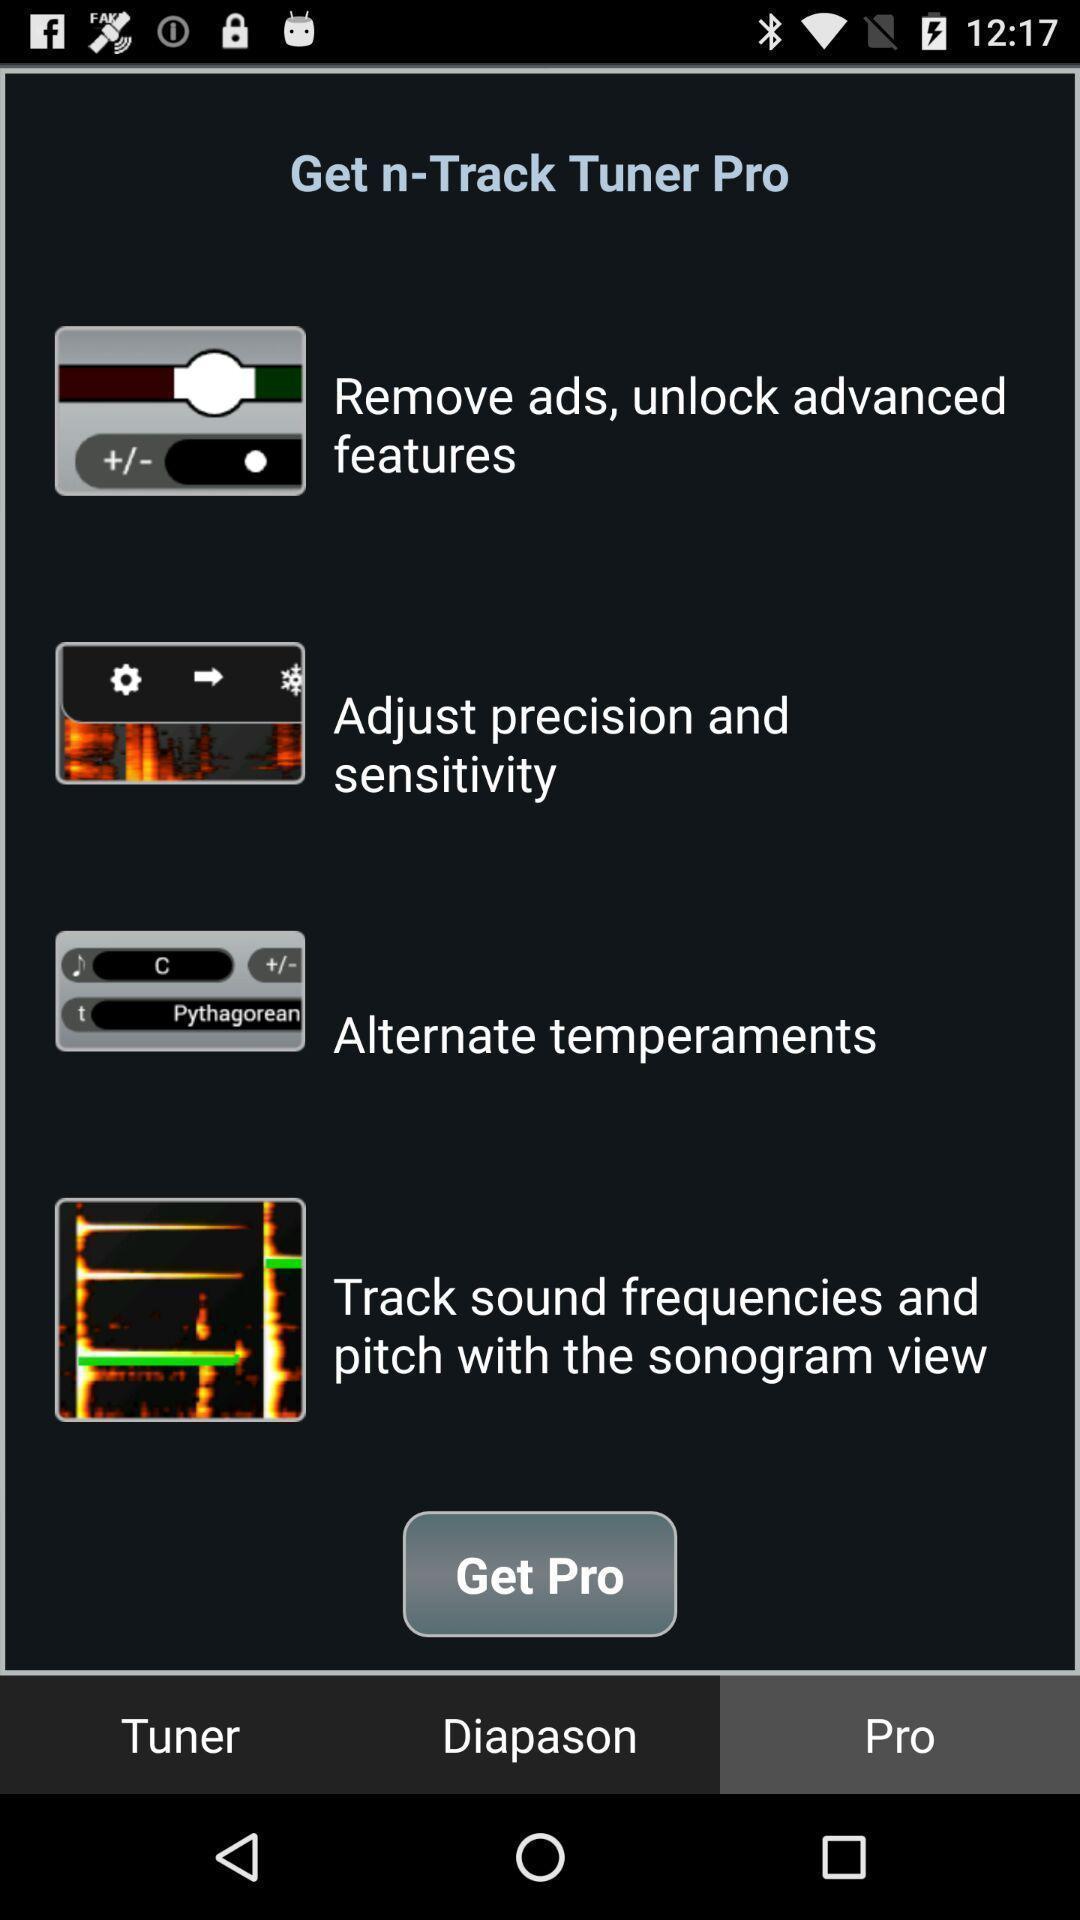Summarize the main components in this picture. Various feed displayed. 